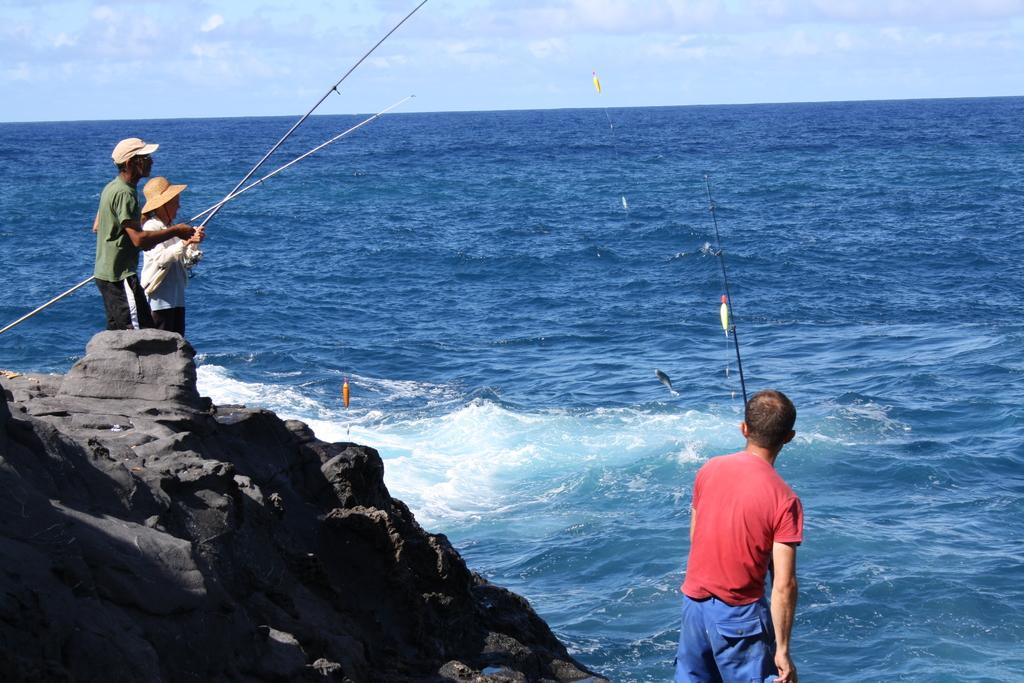How many people are in the image? There are three persons in the image. Where are the persons located in the image? The persons are standing in the center of the image. What are the persons holding in the image? The persons are holding fishing rods. What can be seen in the background of the image? There is sky and water visible in the background of the image. What is the condition of the sky in the image? The sky has clouds in the image. What type of silver object is being used by the persons in the image? There is no silver object visible in the image; the persons are holding fishing rods. What action are the persons about to start in the image? The image does not show the persons starting any action; they are already holding fishing rods. 